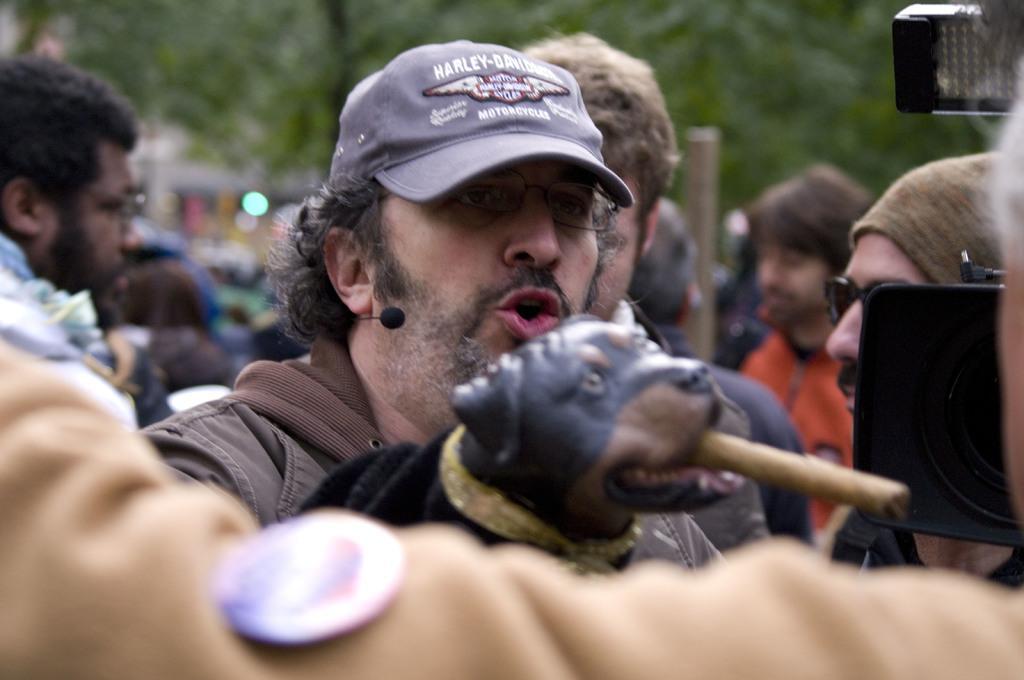How would you summarize this image in a sentence or two? In this image there are a group of people, and in the center there is one person who is wearing cap and he is talking. And there is one dog, and in the dog mouth there is something and on the right side of the image there is a camera and light. In the background there are some trees, and there is a blurry background. 